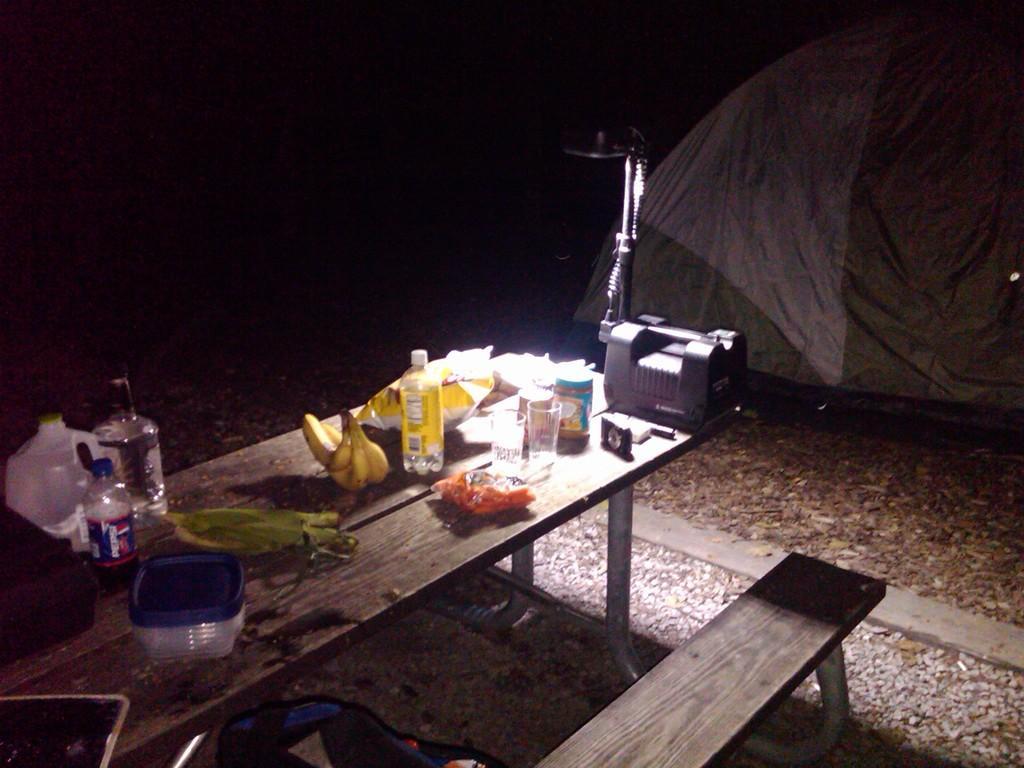In one or two sentences, can you explain what this image depicts? In this image I can see a bench. On the table there are box,bottle,banana,glass and alight. At the back side there is a cover tent. 